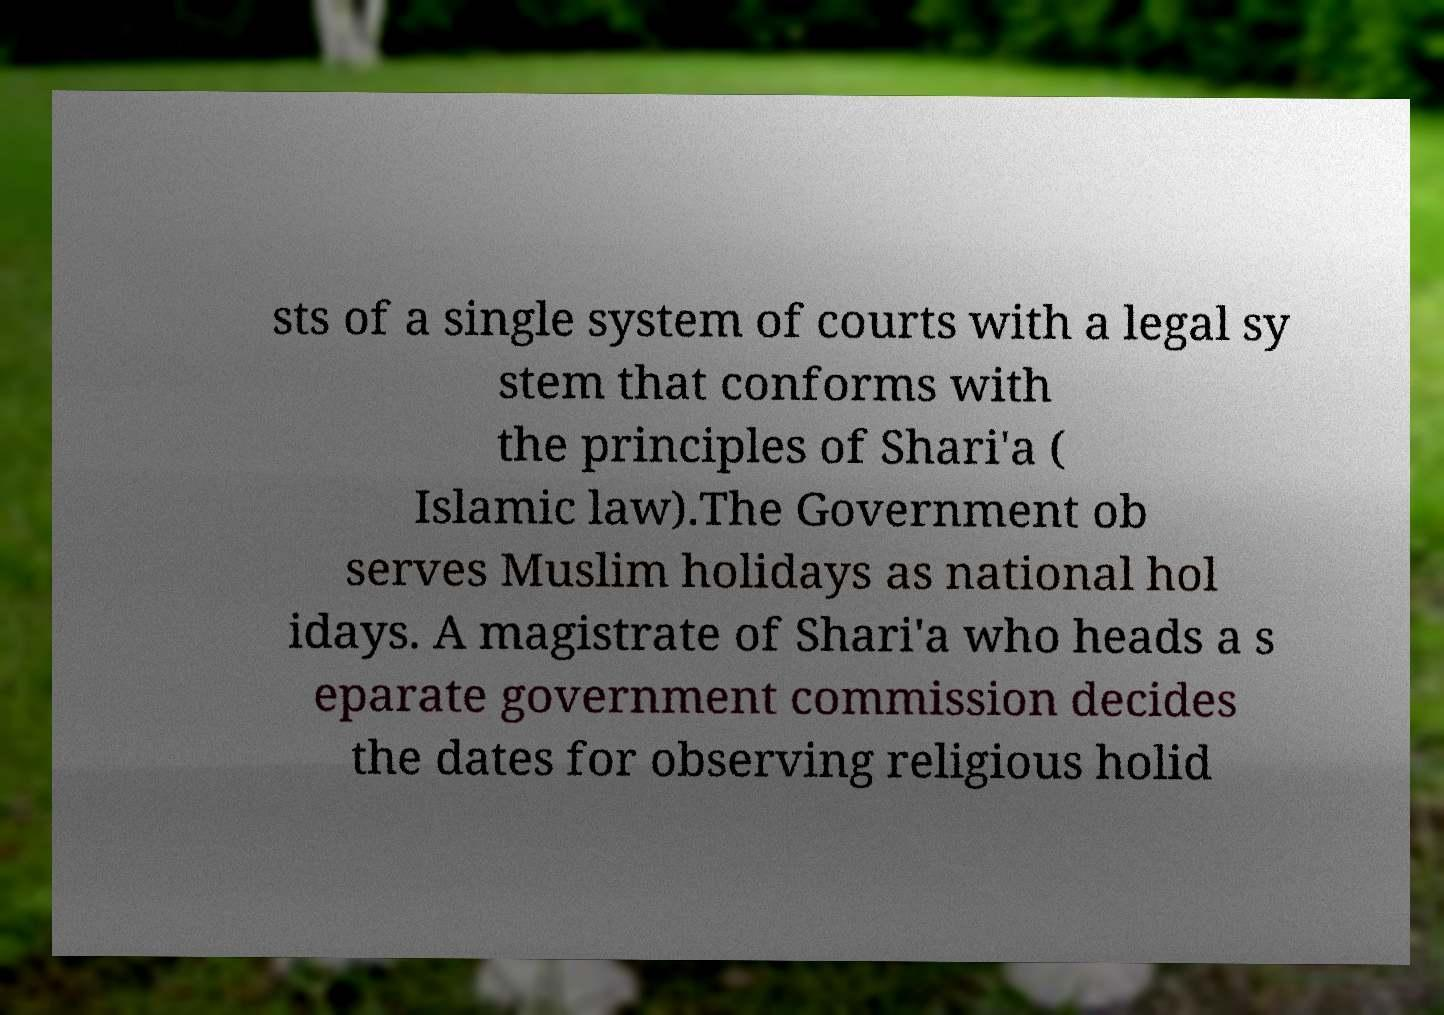Could you extract and type out the text from this image? sts of a single system of courts with a legal sy stem that conforms with the principles of Shari'a ( Islamic law).The Government ob serves Muslim holidays as national hol idays. A magistrate of Shari'a who heads a s eparate government commission decides the dates for observing religious holid 